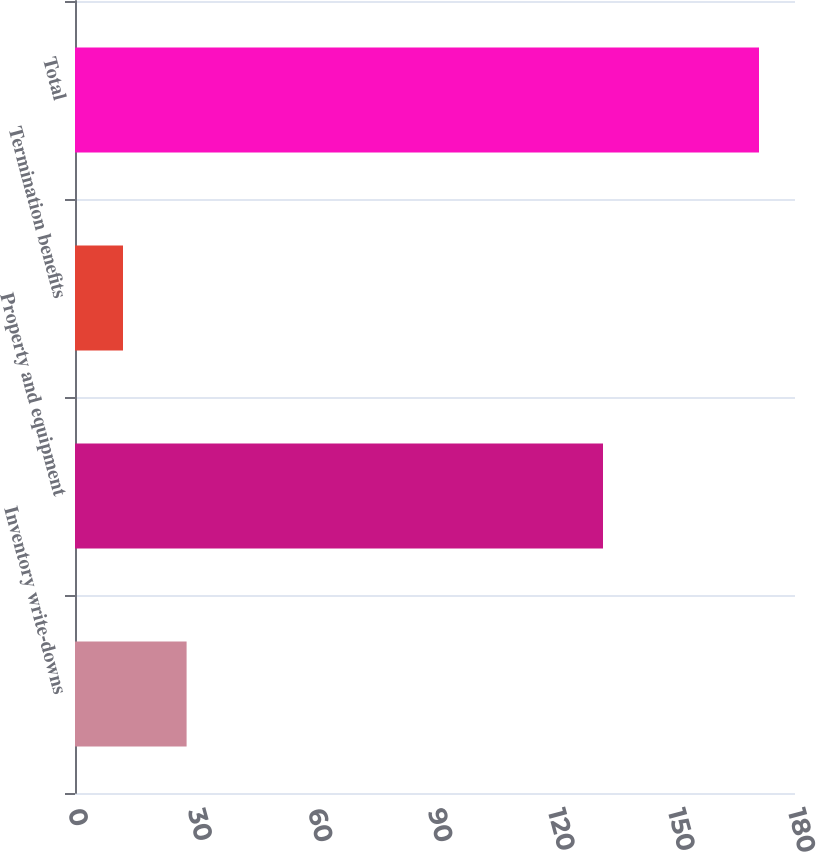Convert chart to OTSL. <chart><loc_0><loc_0><loc_500><loc_500><bar_chart><fcel>Inventory write-downs<fcel>Property and equipment<fcel>Termination benefits<fcel>Total<nl><fcel>27.9<fcel>132<fcel>12<fcel>171<nl></chart> 